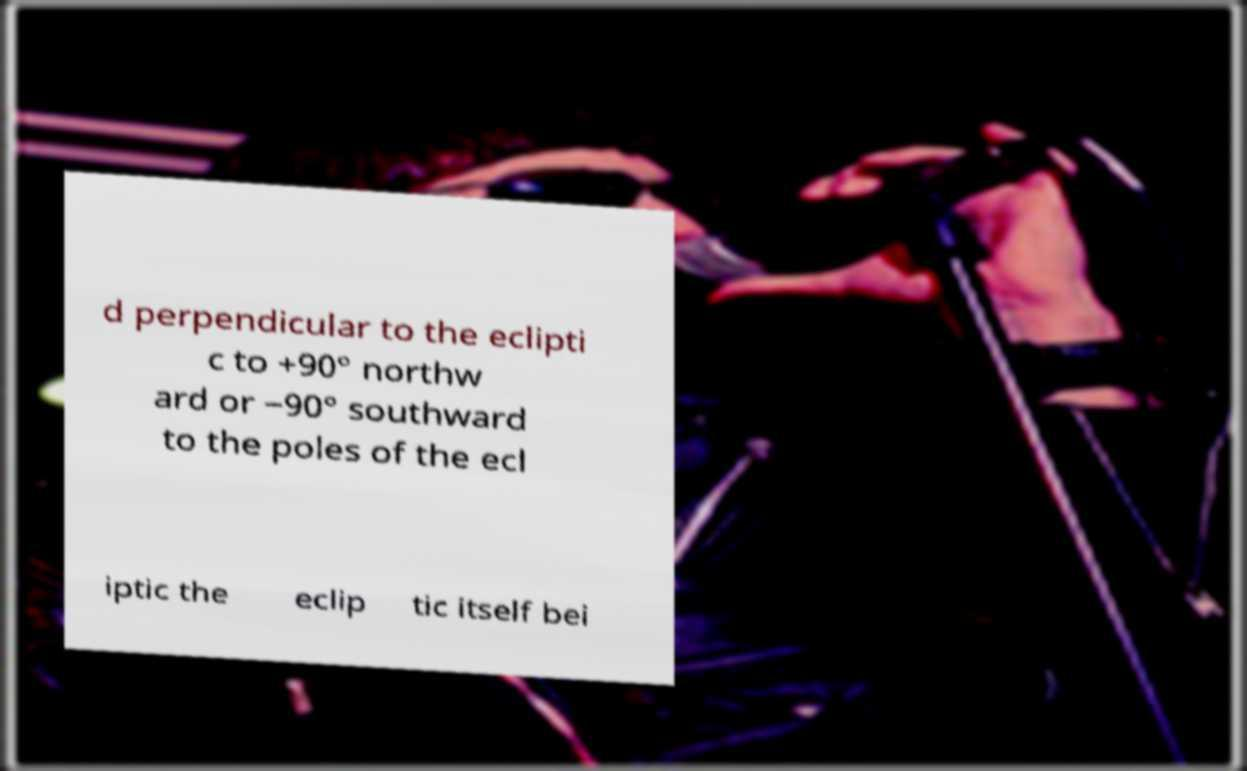Could you extract and type out the text from this image? d perpendicular to the eclipti c to +90° northw ard or −90° southward to the poles of the ecl iptic the eclip tic itself bei 